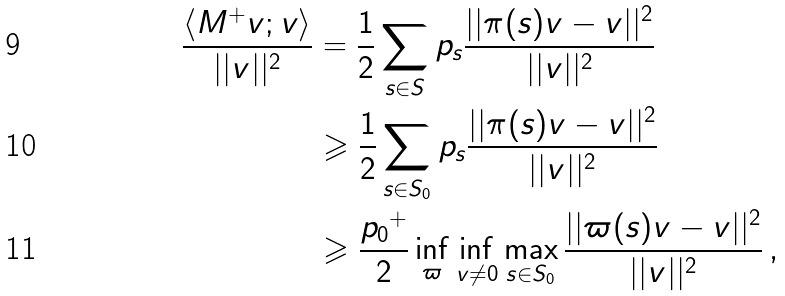Convert formula to latex. <formula><loc_0><loc_0><loc_500><loc_500>\frac { \langle M ^ { + } v ; v \rangle } { | | v | | ^ { 2 } } & = \frac { 1 } { 2 } \sum _ { s \in S } { p _ { s } \frac { | | \pi ( s ) v - v | | ^ { 2 } } { | | v | | ^ { 2 } } } \\ & \geqslant \frac { 1 } { 2 } \sum _ { s \in S _ { 0 } } { p _ { s } \frac { | | \pi ( s ) v - v | | ^ { 2 } } { | | v | | ^ { 2 } } } \\ & \geqslant \frac { { p _ { 0 } } ^ { + } } { 2 } \inf _ { \varpi } \inf _ { v \not = 0 } \max _ { s \in S _ { 0 } } \frac { | | \varpi ( s ) v - v | | ^ { 2 } } { | | v | | ^ { 2 } } \, ,</formula> 